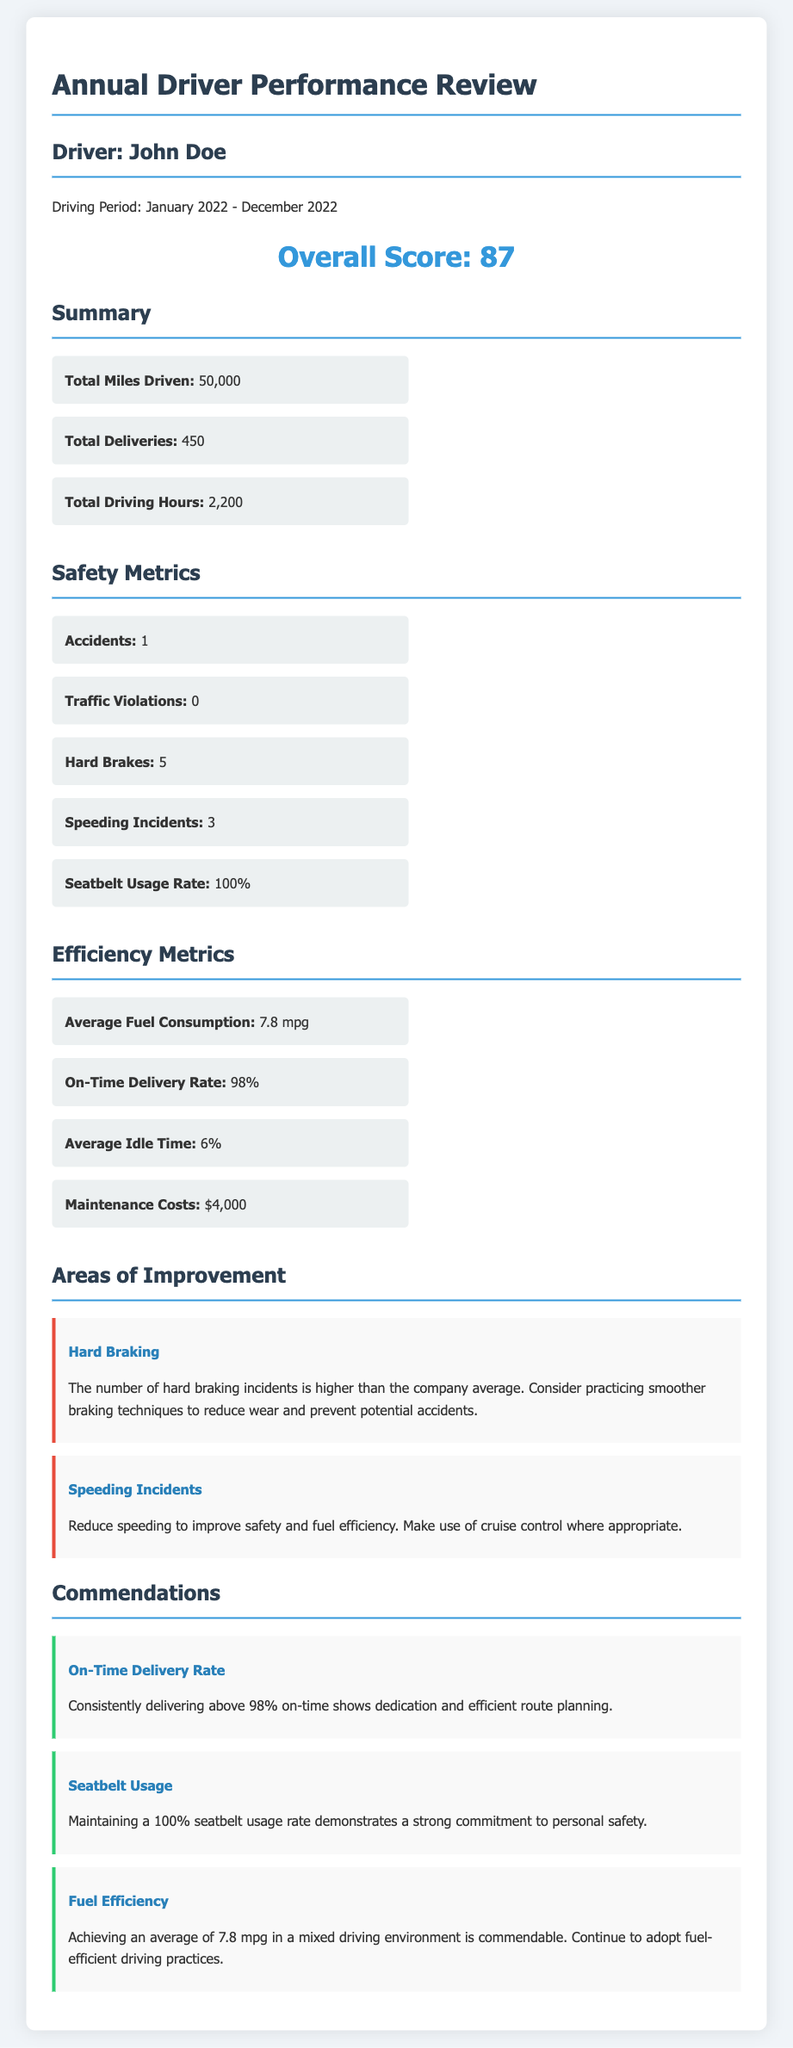What is the overall score for John Doe? The overall score is presented clearly in the document as the main performance score for the driver.
Answer: 87 How many accidents did John Doe have during the review period? The document specifies the number of accidents, which is a key safety metric for the driver's performance review.
Answer: 1 What is the total number of miles driven by John Doe in 2022? Total miles driven is listed in the summary section, reflecting the driver's overall activity for the year.
Answer: 50,000 What is the on-time delivery rate for John Doe? The on-time delivery rate indicates the driver's efficiency and dedication to timely service, which is a commendation highlighted in the review.
Answer: 98% Which area has been identified for improvement related to braking? The improvements section discusses issues related to specific aspects of driving performance based on the metrics evaluated.
Answer: Hard Braking What is John Doe’s seatbelt usage rate? This metric is highlighted as a significant safety measure showing commitment to safety practices during the driving period.
Answer: 100% What was the average fuel consumption for John Doe? Average fuel consumption is an efficiency metric that illustrates the driver's fuel usage in terms of miles per gallon.
Answer: 7.8 mpg Which commendation mentions dedication to personal safety? The commendations section includes various highlights on the driver's performance, focusing on different achievements.
Answer: Seatbelt Usage How many hard brake incidents did John Doe have? The number of hard brake incidents is a safety metric indicating driving behavior during the past year.
Answer: 5 